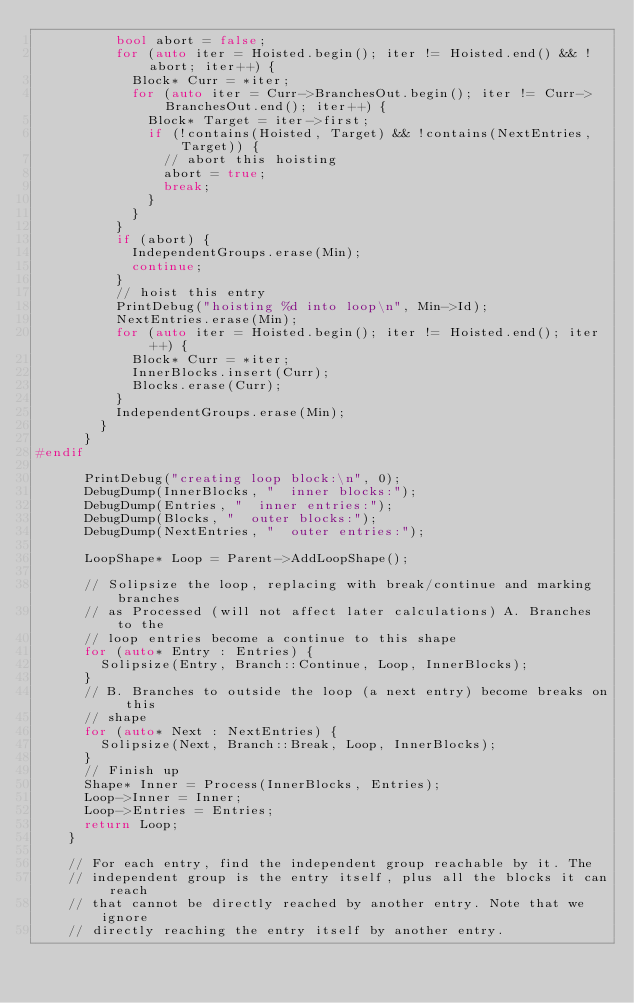Convert code to text. <code><loc_0><loc_0><loc_500><loc_500><_C++_>          bool abort = false;
          for (auto iter = Hoisted.begin(); iter != Hoisted.end() && !abort; iter++) {
            Block* Curr = *iter;
            for (auto iter = Curr->BranchesOut.begin(); iter != Curr->BranchesOut.end(); iter++) {
              Block* Target = iter->first;
              if (!contains(Hoisted, Target) && !contains(NextEntries, Target)) {
                // abort this hoisting
                abort = true;
                break;
              }
            }
          }
          if (abort) {
            IndependentGroups.erase(Min);
            continue;
          }
          // hoist this entry
          PrintDebug("hoisting %d into loop\n", Min->Id);
          NextEntries.erase(Min);
          for (auto iter = Hoisted.begin(); iter != Hoisted.end(); iter++) {
            Block* Curr = *iter;
            InnerBlocks.insert(Curr);
            Blocks.erase(Curr);
          }
          IndependentGroups.erase(Min);
        }
      }
#endif

      PrintDebug("creating loop block:\n", 0);
      DebugDump(InnerBlocks, "  inner blocks:");
      DebugDump(Entries, "  inner entries:");
      DebugDump(Blocks, "  outer blocks:");
      DebugDump(NextEntries, "  outer entries:");

      LoopShape* Loop = Parent->AddLoopShape();

      // Solipsize the loop, replacing with break/continue and marking branches
      // as Processed (will not affect later calculations) A. Branches to the
      // loop entries become a continue to this shape
      for (auto* Entry : Entries) {
        Solipsize(Entry, Branch::Continue, Loop, InnerBlocks);
      }
      // B. Branches to outside the loop (a next entry) become breaks on this
      // shape
      for (auto* Next : NextEntries) {
        Solipsize(Next, Branch::Break, Loop, InnerBlocks);
      }
      // Finish up
      Shape* Inner = Process(InnerBlocks, Entries);
      Loop->Inner = Inner;
      Loop->Entries = Entries;
      return Loop;
    }

    // For each entry, find the independent group reachable by it. The
    // independent group is the entry itself, plus all the blocks it can reach
    // that cannot be directly reached by another entry. Note that we ignore
    // directly reaching the entry itself by another entry.</code> 